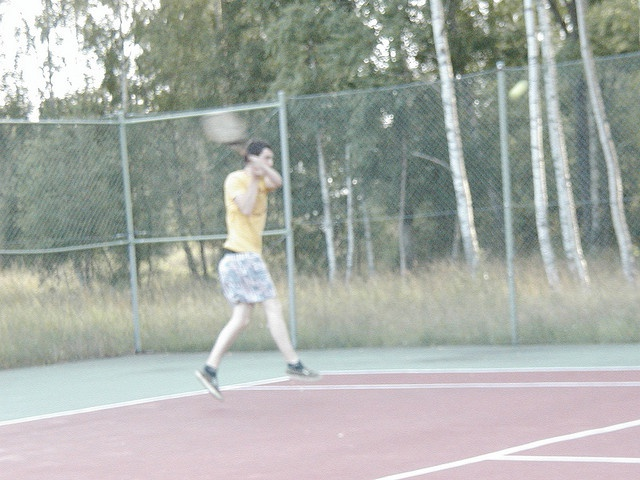Describe the objects in this image and their specific colors. I can see people in lightgray, darkgray, and beige tones, tennis racket in lightgray, darkgray, and gray tones, and sports ball in lightgray, beige, and darkgray tones in this image. 